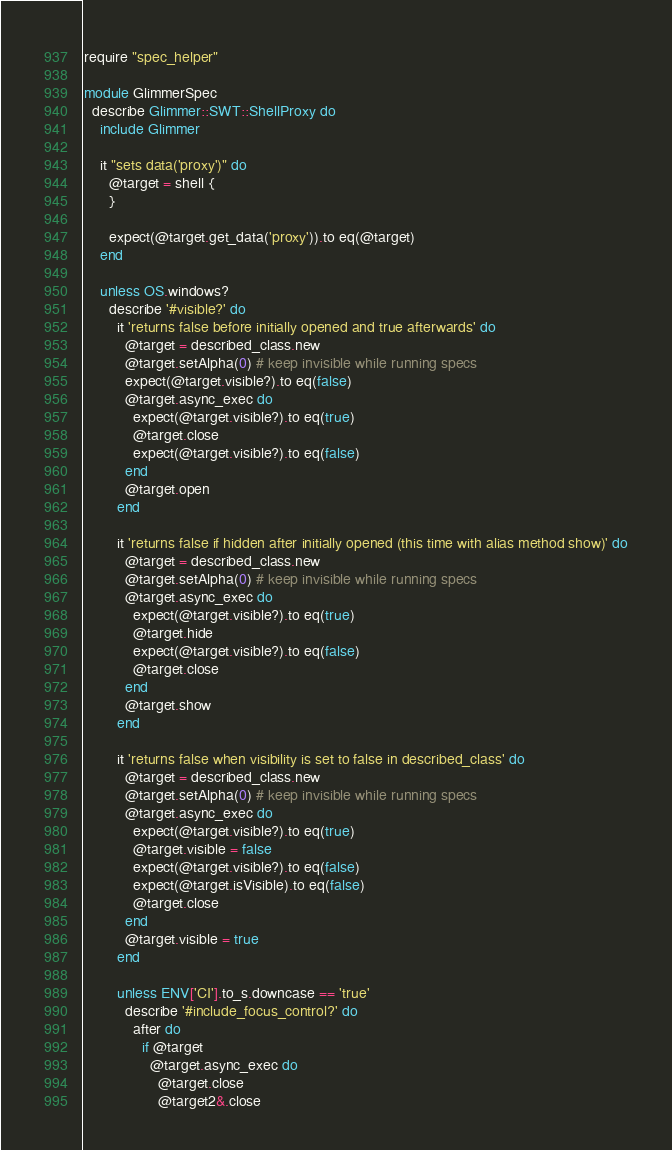Convert code to text. <code><loc_0><loc_0><loc_500><loc_500><_Ruby_>require "spec_helper"

module GlimmerSpec
  describe Glimmer::SWT::ShellProxy do
    include Glimmer

    it "sets data('proxy')" do
      @target = shell {
      }
      
      expect(@target.get_data('proxy')).to eq(@target)
    end
    
    unless OS.windows?
      describe '#visible?' do
        it 'returns false before initially opened and true afterwards' do
          @target = described_class.new
          @target.setAlpha(0) # keep invisible while running specs
          expect(@target.visible?).to eq(false)
          @target.async_exec do
            expect(@target.visible?).to eq(true)
            @target.close
            expect(@target.visible?).to eq(false)
          end
          @target.open
        end
  
        it 'returns false if hidden after initially opened (this time with alias method show)' do
          @target = described_class.new
          @target.setAlpha(0) # keep invisible while running specs
          @target.async_exec do
            expect(@target.visible?).to eq(true)
            @target.hide
            expect(@target.visible?).to eq(false)
            @target.close
          end
          @target.show
        end
  
        it 'returns false when visibility is set to false in described_class' do
          @target = described_class.new
          @target.setAlpha(0) # keep invisible while running specs
          @target.async_exec do
            expect(@target.visible?).to eq(true)
            @target.visible = false
            expect(@target.visible?).to eq(false)
            expect(@target.isVisible).to eq(false)
            @target.close
          end
          @target.visible = true
        end
        
        unless ENV['CI'].to_s.downcase == 'true'
          describe '#include_focus_control?' do
            after do
              if @target
                @target.async_exec do
                  @target.close
                  @target2&.close</code> 